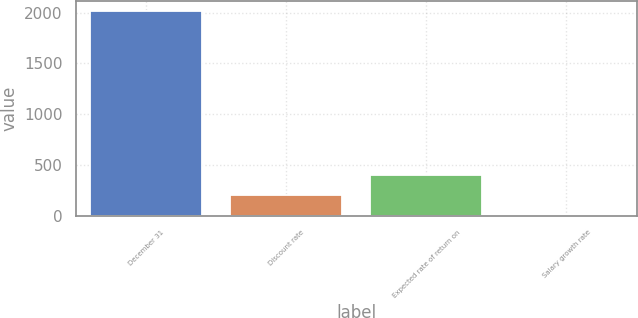Convert chart to OTSL. <chart><loc_0><loc_0><loc_500><loc_500><bar_chart><fcel>December 31<fcel>Discount rate<fcel>Expected rate of return on<fcel>Salary growth rate<nl><fcel>2014<fcel>204.19<fcel>405.28<fcel>3.1<nl></chart> 